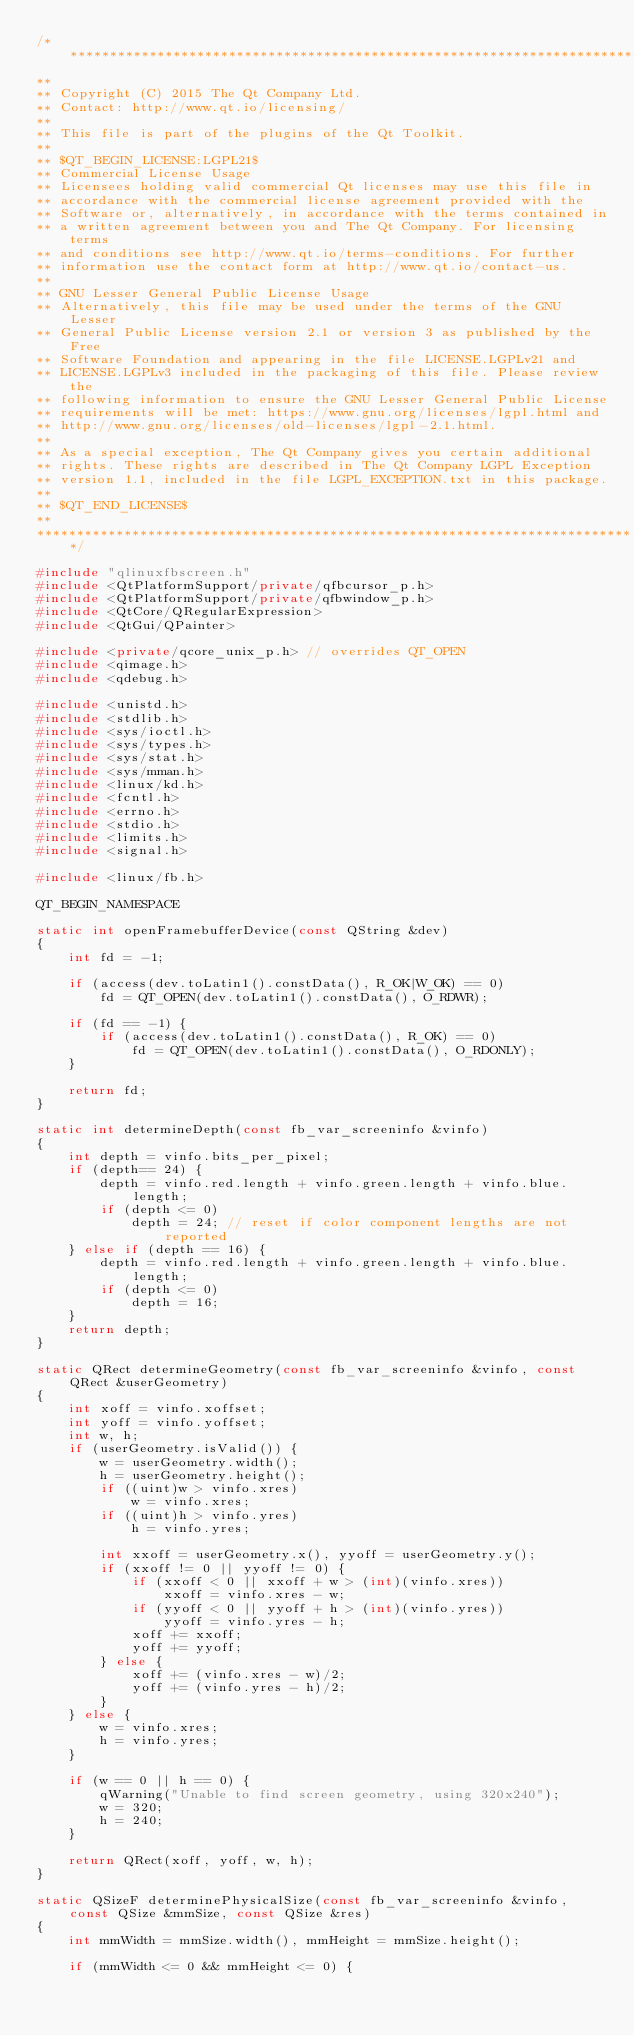<code> <loc_0><loc_0><loc_500><loc_500><_C++_>/****************************************************************************
**
** Copyright (C) 2015 The Qt Company Ltd.
** Contact: http://www.qt.io/licensing/
**
** This file is part of the plugins of the Qt Toolkit.
**
** $QT_BEGIN_LICENSE:LGPL21$
** Commercial License Usage
** Licensees holding valid commercial Qt licenses may use this file in
** accordance with the commercial license agreement provided with the
** Software or, alternatively, in accordance with the terms contained in
** a written agreement between you and The Qt Company. For licensing terms
** and conditions see http://www.qt.io/terms-conditions. For further
** information use the contact form at http://www.qt.io/contact-us.
**
** GNU Lesser General Public License Usage
** Alternatively, this file may be used under the terms of the GNU Lesser
** General Public License version 2.1 or version 3 as published by the Free
** Software Foundation and appearing in the file LICENSE.LGPLv21 and
** LICENSE.LGPLv3 included in the packaging of this file. Please review the
** following information to ensure the GNU Lesser General Public License
** requirements will be met: https://www.gnu.org/licenses/lgpl.html and
** http://www.gnu.org/licenses/old-licenses/lgpl-2.1.html.
**
** As a special exception, The Qt Company gives you certain additional
** rights. These rights are described in The Qt Company LGPL Exception
** version 1.1, included in the file LGPL_EXCEPTION.txt in this package.
**
** $QT_END_LICENSE$
**
****************************************************************************/

#include "qlinuxfbscreen.h"
#include <QtPlatformSupport/private/qfbcursor_p.h>
#include <QtPlatformSupport/private/qfbwindow_p.h>
#include <QtCore/QRegularExpression>
#include <QtGui/QPainter>

#include <private/qcore_unix_p.h> // overrides QT_OPEN
#include <qimage.h>
#include <qdebug.h>

#include <unistd.h>
#include <stdlib.h>
#include <sys/ioctl.h>
#include <sys/types.h>
#include <sys/stat.h>
#include <sys/mman.h>
#include <linux/kd.h>
#include <fcntl.h>
#include <errno.h>
#include <stdio.h>
#include <limits.h>
#include <signal.h>

#include <linux/fb.h>

QT_BEGIN_NAMESPACE

static int openFramebufferDevice(const QString &dev)
{
    int fd = -1;

    if (access(dev.toLatin1().constData(), R_OK|W_OK) == 0)
        fd = QT_OPEN(dev.toLatin1().constData(), O_RDWR);

    if (fd == -1) {
        if (access(dev.toLatin1().constData(), R_OK) == 0)
            fd = QT_OPEN(dev.toLatin1().constData(), O_RDONLY);
    }

    return fd;
}

static int determineDepth(const fb_var_screeninfo &vinfo)
{
    int depth = vinfo.bits_per_pixel;
    if (depth== 24) {
        depth = vinfo.red.length + vinfo.green.length + vinfo.blue.length;
        if (depth <= 0)
            depth = 24; // reset if color component lengths are not reported
    } else if (depth == 16) {
        depth = vinfo.red.length + vinfo.green.length + vinfo.blue.length;
        if (depth <= 0)
            depth = 16;
    }
    return depth;
}

static QRect determineGeometry(const fb_var_screeninfo &vinfo, const QRect &userGeometry)
{
    int xoff = vinfo.xoffset;
    int yoff = vinfo.yoffset;
    int w, h;
    if (userGeometry.isValid()) {
        w = userGeometry.width();
        h = userGeometry.height();
        if ((uint)w > vinfo.xres)
            w = vinfo.xres;
        if ((uint)h > vinfo.yres)
            h = vinfo.yres;

        int xxoff = userGeometry.x(), yyoff = userGeometry.y();
        if (xxoff != 0 || yyoff != 0) {
            if (xxoff < 0 || xxoff + w > (int)(vinfo.xres))
                xxoff = vinfo.xres - w;
            if (yyoff < 0 || yyoff + h > (int)(vinfo.yres))
                yyoff = vinfo.yres - h;
            xoff += xxoff;
            yoff += yyoff;
        } else {
            xoff += (vinfo.xres - w)/2;
            yoff += (vinfo.yres - h)/2;
        }
    } else {
        w = vinfo.xres;
        h = vinfo.yres;
    }

    if (w == 0 || h == 0) {
        qWarning("Unable to find screen geometry, using 320x240");
        w = 320;
        h = 240;
    }

    return QRect(xoff, yoff, w, h);
}

static QSizeF determinePhysicalSize(const fb_var_screeninfo &vinfo, const QSize &mmSize, const QSize &res)
{
    int mmWidth = mmSize.width(), mmHeight = mmSize.height();

    if (mmWidth <= 0 && mmHeight <= 0) {</code> 